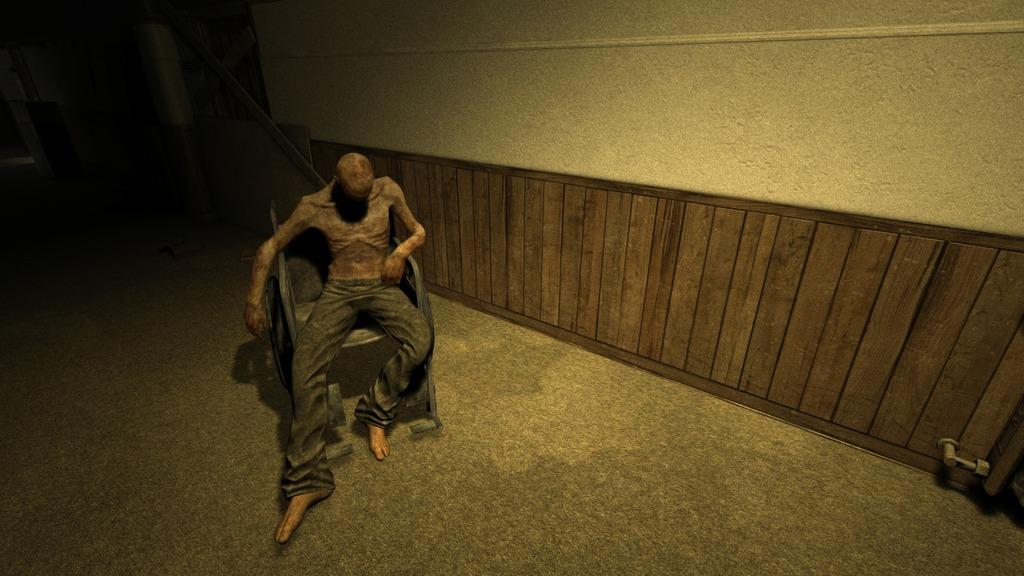What is the main subject of the image? There is a person in the image. What type of clothing is the person wearing? The person is wearing black pants. What is the person doing in the image? The person is sitting in a chair. Can you describe any objects in the background or beside the person? There is a wooden object attached to the wall beside the person. How many clovers can be seen growing on the person's head in the image? There are no clovers visible on the person's head in the image. What type of magic is the person performing in the image? There is no indication of magic or any magical activity in the image. 